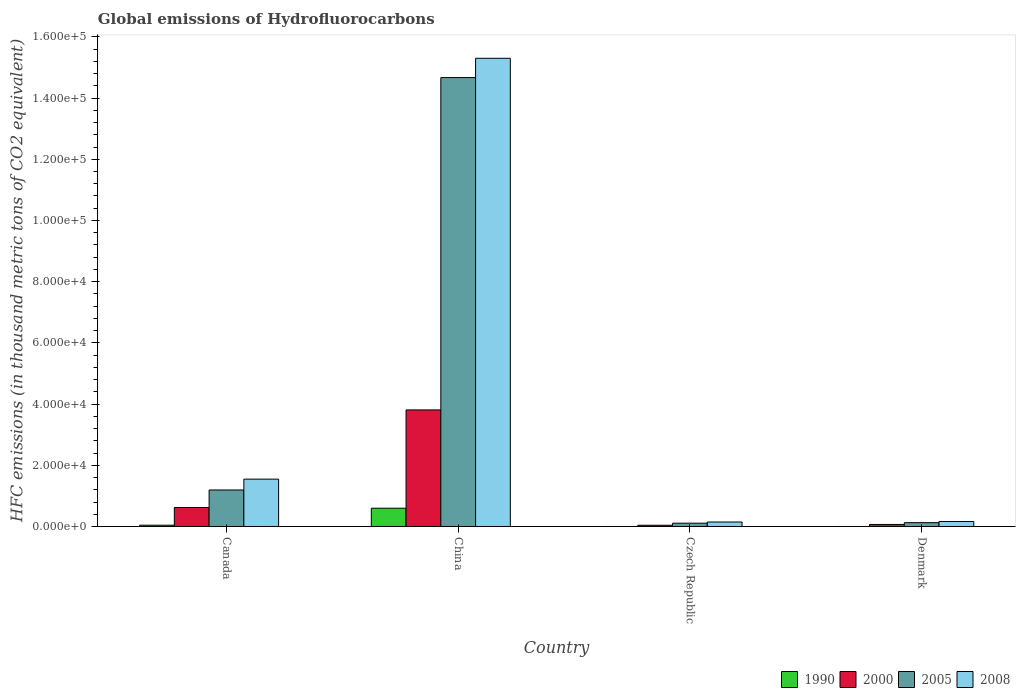How many different coloured bars are there?
Give a very brief answer. 4. Are the number of bars per tick equal to the number of legend labels?
Your answer should be compact. Yes. Are the number of bars on each tick of the X-axis equal?
Give a very brief answer. Yes. How many bars are there on the 4th tick from the left?
Offer a very short reply. 4. How many bars are there on the 4th tick from the right?
Ensure brevity in your answer.  4. What is the global emissions of Hydrofluorocarbons in 1990 in Czech Republic?
Your response must be concise. 0.1. Across all countries, what is the maximum global emissions of Hydrofluorocarbons in 2005?
Offer a terse response. 1.47e+05. In which country was the global emissions of Hydrofluorocarbons in 2005 maximum?
Your response must be concise. China. In which country was the global emissions of Hydrofluorocarbons in 1990 minimum?
Offer a very short reply. Czech Republic. What is the total global emissions of Hydrofluorocarbons in 2000 in the graph?
Provide a succinct answer. 4.54e+04. What is the difference between the global emissions of Hydrofluorocarbons in 2008 in China and that in Denmark?
Ensure brevity in your answer.  1.51e+05. What is the difference between the global emissions of Hydrofluorocarbons in 1990 in China and the global emissions of Hydrofluorocarbons in 2005 in Canada?
Offer a terse response. -5958.3. What is the average global emissions of Hydrofluorocarbons in 2005 per country?
Offer a terse response. 4.02e+04. What is the difference between the global emissions of Hydrofluorocarbons of/in 1990 and global emissions of Hydrofluorocarbons of/in 2005 in China?
Your response must be concise. -1.41e+05. What is the ratio of the global emissions of Hydrofluorocarbons in 2000 in Canada to that in Denmark?
Provide a short and direct response. 9.37. Is the global emissions of Hydrofluorocarbons in 2005 in China less than that in Czech Republic?
Provide a short and direct response. No. Is the difference between the global emissions of Hydrofluorocarbons in 1990 in Canada and Czech Republic greater than the difference between the global emissions of Hydrofluorocarbons in 2005 in Canada and Czech Republic?
Offer a very short reply. No. What is the difference between the highest and the second highest global emissions of Hydrofluorocarbons in 1990?
Offer a terse response. -5551.6. What is the difference between the highest and the lowest global emissions of Hydrofluorocarbons in 1990?
Keep it short and to the point. 5970. Is the sum of the global emissions of Hydrofluorocarbons in 2005 in China and Czech Republic greater than the maximum global emissions of Hydrofluorocarbons in 2000 across all countries?
Your response must be concise. Yes. What does the 3rd bar from the left in China represents?
Offer a very short reply. 2005. What does the 3rd bar from the right in China represents?
Provide a short and direct response. 2000. Are all the bars in the graph horizontal?
Keep it short and to the point. No. Are the values on the major ticks of Y-axis written in scientific E-notation?
Make the answer very short. Yes. Does the graph contain grids?
Your response must be concise. No. How many legend labels are there?
Offer a terse response. 4. What is the title of the graph?
Your answer should be very brief. Global emissions of Hydrofluorocarbons. What is the label or title of the Y-axis?
Give a very brief answer. HFC emissions (in thousand metric tons of CO2 equivalent). What is the HFC emissions (in thousand metric tons of CO2 equivalent) of 1990 in Canada?
Offer a very short reply. 418.5. What is the HFC emissions (in thousand metric tons of CO2 equivalent) in 2000 in Canada?
Make the answer very short. 6202.8. What is the HFC emissions (in thousand metric tons of CO2 equivalent) of 2005 in Canada?
Your answer should be compact. 1.19e+04. What is the HFC emissions (in thousand metric tons of CO2 equivalent) in 2008 in Canada?
Offer a terse response. 1.55e+04. What is the HFC emissions (in thousand metric tons of CO2 equivalent) in 1990 in China?
Ensure brevity in your answer.  5970.1. What is the HFC emissions (in thousand metric tons of CO2 equivalent) of 2000 in China?
Provide a succinct answer. 3.81e+04. What is the HFC emissions (in thousand metric tons of CO2 equivalent) of 2005 in China?
Your answer should be very brief. 1.47e+05. What is the HFC emissions (in thousand metric tons of CO2 equivalent) of 2008 in China?
Your response must be concise. 1.53e+05. What is the HFC emissions (in thousand metric tons of CO2 equivalent) of 1990 in Czech Republic?
Make the answer very short. 0.1. What is the HFC emissions (in thousand metric tons of CO2 equivalent) in 2000 in Czech Republic?
Keep it short and to the point. 399.5. What is the HFC emissions (in thousand metric tons of CO2 equivalent) of 2005 in Czech Republic?
Give a very brief answer. 1078.7. What is the HFC emissions (in thousand metric tons of CO2 equivalent) in 2008 in Czech Republic?
Offer a very short reply. 1459. What is the HFC emissions (in thousand metric tons of CO2 equivalent) in 2000 in Denmark?
Make the answer very short. 662.2. What is the HFC emissions (in thousand metric tons of CO2 equivalent) in 2005 in Denmark?
Offer a terse response. 1249.5. What is the HFC emissions (in thousand metric tons of CO2 equivalent) of 2008 in Denmark?
Give a very brief answer. 1629.6. Across all countries, what is the maximum HFC emissions (in thousand metric tons of CO2 equivalent) in 1990?
Provide a short and direct response. 5970.1. Across all countries, what is the maximum HFC emissions (in thousand metric tons of CO2 equivalent) in 2000?
Make the answer very short. 3.81e+04. Across all countries, what is the maximum HFC emissions (in thousand metric tons of CO2 equivalent) in 2005?
Keep it short and to the point. 1.47e+05. Across all countries, what is the maximum HFC emissions (in thousand metric tons of CO2 equivalent) of 2008?
Offer a terse response. 1.53e+05. Across all countries, what is the minimum HFC emissions (in thousand metric tons of CO2 equivalent) of 2000?
Your answer should be compact. 399.5. Across all countries, what is the minimum HFC emissions (in thousand metric tons of CO2 equivalent) in 2005?
Keep it short and to the point. 1078.7. Across all countries, what is the minimum HFC emissions (in thousand metric tons of CO2 equivalent) in 2008?
Your answer should be compact. 1459. What is the total HFC emissions (in thousand metric tons of CO2 equivalent) in 1990 in the graph?
Provide a succinct answer. 6389. What is the total HFC emissions (in thousand metric tons of CO2 equivalent) of 2000 in the graph?
Your answer should be very brief. 4.54e+04. What is the total HFC emissions (in thousand metric tons of CO2 equivalent) of 2005 in the graph?
Provide a succinct answer. 1.61e+05. What is the total HFC emissions (in thousand metric tons of CO2 equivalent) in 2008 in the graph?
Offer a terse response. 1.72e+05. What is the difference between the HFC emissions (in thousand metric tons of CO2 equivalent) of 1990 in Canada and that in China?
Your answer should be compact. -5551.6. What is the difference between the HFC emissions (in thousand metric tons of CO2 equivalent) in 2000 in Canada and that in China?
Offer a very short reply. -3.19e+04. What is the difference between the HFC emissions (in thousand metric tons of CO2 equivalent) in 2005 in Canada and that in China?
Your answer should be compact. -1.35e+05. What is the difference between the HFC emissions (in thousand metric tons of CO2 equivalent) in 2008 in Canada and that in China?
Provide a short and direct response. -1.38e+05. What is the difference between the HFC emissions (in thousand metric tons of CO2 equivalent) in 1990 in Canada and that in Czech Republic?
Provide a succinct answer. 418.4. What is the difference between the HFC emissions (in thousand metric tons of CO2 equivalent) of 2000 in Canada and that in Czech Republic?
Keep it short and to the point. 5803.3. What is the difference between the HFC emissions (in thousand metric tons of CO2 equivalent) in 2005 in Canada and that in Czech Republic?
Make the answer very short. 1.08e+04. What is the difference between the HFC emissions (in thousand metric tons of CO2 equivalent) of 2008 in Canada and that in Czech Republic?
Offer a very short reply. 1.40e+04. What is the difference between the HFC emissions (in thousand metric tons of CO2 equivalent) in 1990 in Canada and that in Denmark?
Your answer should be compact. 418.2. What is the difference between the HFC emissions (in thousand metric tons of CO2 equivalent) in 2000 in Canada and that in Denmark?
Provide a short and direct response. 5540.6. What is the difference between the HFC emissions (in thousand metric tons of CO2 equivalent) of 2005 in Canada and that in Denmark?
Your response must be concise. 1.07e+04. What is the difference between the HFC emissions (in thousand metric tons of CO2 equivalent) of 2008 in Canada and that in Denmark?
Give a very brief answer. 1.38e+04. What is the difference between the HFC emissions (in thousand metric tons of CO2 equivalent) in 1990 in China and that in Czech Republic?
Give a very brief answer. 5970. What is the difference between the HFC emissions (in thousand metric tons of CO2 equivalent) in 2000 in China and that in Czech Republic?
Keep it short and to the point. 3.77e+04. What is the difference between the HFC emissions (in thousand metric tons of CO2 equivalent) of 2005 in China and that in Czech Republic?
Provide a succinct answer. 1.46e+05. What is the difference between the HFC emissions (in thousand metric tons of CO2 equivalent) of 2008 in China and that in Czech Republic?
Offer a terse response. 1.52e+05. What is the difference between the HFC emissions (in thousand metric tons of CO2 equivalent) of 1990 in China and that in Denmark?
Ensure brevity in your answer.  5969.8. What is the difference between the HFC emissions (in thousand metric tons of CO2 equivalent) in 2000 in China and that in Denmark?
Provide a short and direct response. 3.74e+04. What is the difference between the HFC emissions (in thousand metric tons of CO2 equivalent) in 2005 in China and that in Denmark?
Your response must be concise. 1.45e+05. What is the difference between the HFC emissions (in thousand metric tons of CO2 equivalent) of 2008 in China and that in Denmark?
Your answer should be very brief. 1.51e+05. What is the difference between the HFC emissions (in thousand metric tons of CO2 equivalent) in 2000 in Czech Republic and that in Denmark?
Ensure brevity in your answer.  -262.7. What is the difference between the HFC emissions (in thousand metric tons of CO2 equivalent) in 2005 in Czech Republic and that in Denmark?
Give a very brief answer. -170.8. What is the difference between the HFC emissions (in thousand metric tons of CO2 equivalent) in 2008 in Czech Republic and that in Denmark?
Offer a very short reply. -170.6. What is the difference between the HFC emissions (in thousand metric tons of CO2 equivalent) in 1990 in Canada and the HFC emissions (in thousand metric tons of CO2 equivalent) in 2000 in China?
Provide a short and direct response. -3.77e+04. What is the difference between the HFC emissions (in thousand metric tons of CO2 equivalent) of 1990 in Canada and the HFC emissions (in thousand metric tons of CO2 equivalent) of 2005 in China?
Your answer should be compact. -1.46e+05. What is the difference between the HFC emissions (in thousand metric tons of CO2 equivalent) of 1990 in Canada and the HFC emissions (in thousand metric tons of CO2 equivalent) of 2008 in China?
Offer a very short reply. -1.53e+05. What is the difference between the HFC emissions (in thousand metric tons of CO2 equivalent) of 2000 in Canada and the HFC emissions (in thousand metric tons of CO2 equivalent) of 2005 in China?
Offer a terse response. -1.40e+05. What is the difference between the HFC emissions (in thousand metric tons of CO2 equivalent) of 2000 in Canada and the HFC emissions (in thousand metric tons of CO2 equivalent) of 2008 in China?
Provide a succinct answer. -1.47e+05. What is the difference between the HFC emissions (in thousand metric tons of CO2 equivalent) of 2005 in Canada and the HFC emissions (in thousand metric tons of CO2 equivalent) of 2008 in China?
Your answer should be very brief. -1.41e+05. What is the difference between the HFC emissions (in thousand metric tons of CO2 equivalent) in 1990 in Canada and the HFC emissions (in thousand metric tons of CO2 equivalent) in 2005 in Czech Republic?
Keep it short and to the point. -660.2. What is the difference between the HFC emissions (in thousand metric tons of CO2 equivalent) of 1990 in Canada and the HFC emissions (in thousand metric tons of CO2 equivalent) of 2008 in Czech Republic?
Provide a succinct answer. -1040.5. What is the difference between the HFC emissions (in thousand metric tons of CO2 equivalent) of 2000 in Canada and the HFC emissions (in thousand metric tons of CO2 equivalent) of 2005 in Czech Republic?
Your answer should be very brief. 5124.1. What is the difference between the HFC emissions (in thousand metric tons of CO2 equivalent) of 2000 in Canada and the HFC emissions (in thousand metric tons of CO2 equivalent) of 2008 in Czech Republic?
Your response must be concise. 4743.8. What is the difference between the HFC emissions (in thousand metric tons of CO2 equivalent) of 2005 in Canada and the HFC emissions (in thousand metric tons of CO2 equivalent) of 2008 in Czech Republic?
Your answer should be compact. 1.05e+04. What is the difference between the HFC emissions (in thousand metric tons of CO2 equivalent) in 1990 in Canada and the HFC emissions (in thousand metric tons of CO2 equivalent) in 2000 in Denmark?
Your response must be concise. -243.7. What is the difference between the HFC emissions (in thousand metric tons of CO2 equivalent) of 1990 in Canada and the HFC emissions (in thousand metric tons of CO2 equivalent) of 2005 in Denmark?
Provide a short and direct response. -831. What is the difference between the HFC emissions (in thousand metric tons of CO2 equivalent) in 1990 in Canada and the HFC emissions (in thousand metric tons of CO2 equivalent) in 2008 in Denmark?
Ensure brevity in your answer.  -1211.1. What is the difference between the HFC emissions (in thousand metric tons of CO2 equivalent) in 2000 in Canada and the HFC emissions (in thousand metric tons of CO2 equivalent) in 2005 in Denmark?
Offer a very short reply. 4953.3. What is the difference between the HFC emissions (in thousand metric tons of CO2 equivalent) in 2000 in Canada and the HFC emissions (in thousand metric tons of CO2 equivalent) in 2008 in Denmark?
Ensure brevity in your answer.  4573.2. What is the difference between the HFC emissions (in thousand metric tons of CO2 equivalent) of 2005 in Canada and the HFC emissions (in thousand metric tons of CO2 equivalent) of 2008 in Denmark?
Offer a terse response. 1.03e+04. What is the difference between the HFC emissions (in thousand metric tons of CO2 equivalent) of 1990 in China and the HFC emissions (in thousand metric tons of CO2 equivalent) of 2000 in Czech Republic?
Provide a short and direct response. 5570.6. What is the difference between the HFC emissions (in thousand metric tons of CO2 equivalent) in 1990 in China and the HFC emissions (in thousand metric tons of CO2 equivalent) in 2005 in Czech Republic?
Your response must be concise. 4891.4. What is the difference between the HFC emissions (in thousand metric tons of CO2 equivalent) in 1990 in China and the HFC emissions (in thousand metric tons of CO2 equivalent) in 2008 in Czech Republic?
Keep it short and to the point. 4511.1. What is the difference between the HFC emissions (in thousand metric tons of CO2 equivalent) in 2000 in China and the HFC emissions (in thousand metric tons of CO2 equivalent) in 2005 in Czech Republic?
Your answer should be very brief. 3.70e+04. What is the difference between the HFC emissions (in thousand metric tons of CO2 equivalent) in 2000 in China and the HFC emissions (in thousand metric tons of CO2 equivalent) in 2008 in Czech Republic?
Provide a succinct answer. 3.66e+04. What is the difference between the HFC emissions (in thousand metric tons of CO2 equivalent) in 2005 in China and the HFC emissions (in thousand metric tons of CO2 equivalent) in 2008 in Czech Republic?
Offer a terse response. 1.45e+05. What is the difference between the HFC emissions (in thousand metric tons of CO2 equivalent) of 1990 in China and the HFC emissions (in thousand metric tons of CO2 equivalent) of 2000 in Denmark?
Offer a very short reply. 5307.9. What is the difference between the HFC emissions (in thousand metric tons of CO2 equivalent) of 1990 in China and the HFC emissions (in thousand metric tons of CO2 equivalent) of 2005 in Denmark?
Provide a succinct answer. 4720.6. What is the difference between the HFC emissions (in thousand metric tons of CO2 equivalent) in 1990 in China and the HFC emissions (in thousand metric tons of CO2 equivalent) in 2008 in Denmark?
Your answer should be very brief. 4340.5. What is the difference between the HFC emissions (in thousand metric tons of CO2 equivalent) of 2000 in China and the HFC emissions (in thousand metric tons of CO2 equivalent) of 2005 in Denmark?
Your answer should be very brief. 3.68e+04. What is the difference between the HFC emissions (in thousand metric tons of CO2 equivalent) of 2000 in China and the HFC emissions (in thousand metric tons of CO2 equivalent) of 2008 in Denmark?
Provide a short and direct response. 3.65e+04. What is the difference between the HFC emissions (in thousand metric tons of CO2 equivalent) in 2005 in China and the HFC emissions (in thousand metric tons of CO2 equivalent) in 2008 in Denmark?
Provide a short and direct response. 1.45e+05. What is the difference between the HFC emissions (in thousand metric tons of CO2 equivalent) in 1990 in Czech Republic and the HFC emissions (in thousand metric tons of CO2 equivalent) in 2000 in Denmark?
Provide a succinct answer. -662.1. What is the difference between the HFC emissions (in thousand metric tons of CO2 equivalent) in 1990 in Czech Republic and the HFC emissions (in thousand metric tons of CO2 equivalent) in 2005 in Denmark?
Give a very brief answer. -1249.4. What is the difference between the HFC emissions (in thousand metric tons of CO2 equivalent) of 1990 in Czech Republic and the HFC emissions (in thousand metric tons of CO2 equivalent) of 2008 in Denmark?
Make the answer very short. -1629.5. What is the difference between the HFC emissions (in thousand metric tons of CO2 equivalent) in 2000 in Czech Republic and the HFC emissions (in thousand metric tons of CO2 equivalent) in 2005 in Denmark?
Ensure brevity in your answer.  -850. What is the difference between the HFC emissions (in thousand metric tons of CO2 equivalent) in 2000 in Czech Republic and the HFC emissions (in thousand metric tons of CO2 equivalent) in 2008 in Denmark?
Give a very brief answer. -1230.1. What is the difference between the HFC emissions (in thousand metric tons of CO2 equivalent) in 2005 in Czech Republic and the HFC emissions (in thousand metric tons of CO2 equivalent) in 2008 in Denmark?
Your answer should be very brief. -550.9. What is the average HFC emissions (in thousand metric tons of CO2 equivalent) in 1990 per country?
Your answer should be very brief. 1597.25. What is the average HFC emissions (in thousand metric tons of CO2 equivalent) in 2000 per country?
Your answer should be compact. 1.13e+04. What is the average HFC emissions (in thousand metric tons of CO2 equivalent) of 2005 per country?
Make the answer very short. 4.02e+04. What is the average HFC emissions (in thousand metric tons of CO2 equivalent) of 2008 per country?
Give a very brief answer. 4.29e+04. What is the difference between the HFC emissions (in thousand metric tons of CO2 equivalent) of 1990 and HFC emissions (in thousand metric tons of CO2 equivalent) of 2000 in Canada?
Your answer should be compact. -5784.3. What is the difference between the HFC emissions (in thousand metric tons of CO2 equivalent) of 1990 and HFC emissions (in thousand metric tons of CO2 equivalent) of 2005 in Canada?
Ensure brevity in your answer.  -1.15e+04. What is the difference between the HFC emissions (in thousand metric tons of CO2 equivalent) in 1990 and HFC emissions (in thousand metric tons of CO2 equivalent) in 2008 in Canada?
Give a very brief answer. -1.51e+04. What is the difference between the HFC emissions (in thousand metric tons of CO2 equivalent) in 2000 and HFC emissions (in thousand metric tons of CO2 equivalent) in 2005 in Canada?
Your answer should be very brief. -5725.6. What is the difference between the HFC emissions (in thousand metric tons of CO2 equivalent) in 2000 and HFC emissions (in thousand metric tons of CO2 equivalent) in 2008 in Canada?
Your answer should be very brief. -9272. What is the difference between the HFC emissions (in thousand metric tons of CO2 equivalent) in 2005 and HFC emissions (in thousand metric tons of CO2 equivalent) in 2008 in Canada?
Offer a very short reply. -3546.4. What is the difference between the HFC emissions (in thousand metric tons of CO2 equivalent) of 1990 and HFC emissions (in thousand metric tons of CO2 equivalent) of 2000 in China?
Make the answer very short. -3.21e+04. What is the difference between the HFC emissions (in thousand metric tons of CO2 equivalent) of 1990 and HFC emissions (in thousand metric tons of CO2 equivalent) of 2005 in China?
Ensure brevity in your answer.  -1.41e+05. What is the difference between the HFC emissions (in thousand metric tons of CO2 equivalent) of 1990 and HFC emissions (in thousand metric tons of CO2 equivalent) of 2008 in China?
Keep it short and to the point. -1.47e+05. What is the difference between the HFC emissions (in thousand metric tons of CO2 equivalent) in 2000 and HFC emissions (in thousand metric tons of CO2 equivalent) in 2005 in China?
Give a very brief answer. -1.09e+05. What is the difference between the HFC emissions (in thousand metric tons of CO2 equivalent) in 2000 and HFC emissions (in thousand metric tons of CO2 equivalent) in 2008 in China?
Provide a short and direct response. -1.15e+05. What is the difference between the HFC emissions (in thousand metric tons of CO2 equivalent) in 2005 and HFC emissions (in thousand metric tons of CO2 equivalent) in 2008 in China?
Offer a terse response. -6309. What is the difference between the HFC emissions (in thousand metric tons of CO2 equivalent) in 1990 and HFC emissions (in thousand metric tons of CO2 equivalent) in 2000 in Czech Republic?
Give a very brief answer. -399.4. What is the difference between the HFC emissions (in thousand metric tons of CO2 equivalent) in 1990 and HFC emissions (in thousand metric tons of CO2 equivalent) in 2005 in Czech Republic?
Give a very brief answer. -1078.6. What is the difference between the HFC emissions (in thousand metric tons of CO2 equivalent) of 1990 and HFC emissions (in thousand metric tons of CO2 equivalent) of 2008 in Czech Republic?
Your answer should be very brief. -1458.9. What is the difference between the HFC emissions (in thousand metric tons of CO2 equivalent) in 2000 and HFC emissions (in thousand metric tons of CO2 equivalent) in 2005 in Czech Republic?
Provide a succinct answer. -679.2. What is the difference between the HFC emissions (in thousand metric tons of CO2 equivalent) in 2000 and HFC emissions (in thousand metric tons of CO2 equivalent) in 2008 in Czech Republic?
Your answer should be compact. -1059.5. What is the difference between the HFC emissions (in thousand metric tons of CO2 equivalent) of 2005 and HFC emissions (in thousand metric tons of CO2 equivalent) of 2008 in Czech Republic?
Your response must be concise. -380.3. What is the difference between the HFC emissions (in thousand metric tons of CO2 equivalent) in 1990 and HFC emissions (in thousand metric tons of CO2 equivalent) in 2000 in Denmark?
Provide a short and direct response. -661.9. What is the difference between the HFC emissions (in thousand metric tons of CO2 equivalent) in 1990 and HFC emissions (in thousand metric tons of CO2 equivalent) in 2005 in Denmark?
Provide a succinct answer. -1249.2. What is the difference between the HFC emissions (in thousand metric tons of CO2 equivalent) of 1990 and HFC emissions (in thousand metric tons of CO2 equivalent) of 2008 in Denmark?
Ensure brevity in your answer.  -1629.3. What is the difference between the HFC emissions (in thousand metric tons of CO2 equivalent) of 2000 and HFC emissions (in thousand metric tons of CO2 equivalent) of 2005 in Denmark?
Ensure brevity in your answer.  -587.3. What is the difference between the HFC emissions (in thousand metric tons of CO2 equivalent) in 2000 and HFC emissions (in thousand metric tons of CO2 equivalent) in 2008 in Denmark?
Provide a succinct answer. -967.4. What is the difference between the HFC emissions (in thousand metric tons of CO2 equivalent) in 2005 and HFC emissions (in thousand metric tons of CO2 equivalent) in 2008 in Denmark?
Your answer should be compact. -380.1. What is the ratio of the HFC emissions (in thousand metric tons of CO2 equivalent) of 1990 in Canada to that in China?
Offer a very short reply. 0.07. What is the ratio of the HFC emissions (in thousand metric tons of CO2 equivalent) in 2000 in Canada to that in China?
Give a very brief answer. 0.16. What is the ratio of the HFC emissions (in thousand metric tons of CO2 equivalent) of 2005 in Canada to that in China?
Provide a succinct answer. 0.08. What is the ratio of the HFC emissions (in thousand metric tons of CO2 equivalent) in 2008 in Canada to that in China?
Keep it short and to the point. 0.1. What is the ratio of the HFC emissions (in thousand metric tons of CO2 equivalent) of 1990 in Canada to that in Czech Republic?
Offer a terse response. 4185. What is the ratio of the HFC emissions (in thousand metric tons of CO2 equivalent) of 2000 in Canada to that in Czech Republic?
Make the answer very short. 15.53. What is the ratio of the HFC emissions (in thousand metric tons of CO2 equivalent) in 2005 in Canada to that in Czech Republic?
Provide a short and direct response. 11.06. What is the ratio of the HFC emissions (in thousand metric tons of CO2 equivalent) in 2008 in Canada to that in Czech Republic?
Your answer should be compact. 10.61. What is the ratio of the HFC emissions (in thousand metric tons of CO2 equivalent) of 1990 in Canada to that in Denmark?
Offer a very short reply. 1395. What is the ratio of the HFC emissions (in thousand metric tons of CO2 equivalent) of 2000 in Canada to that in Denmark?
Offer a very short reply. 9.37. What is the ratio of the HFC emissions (in thousand metric tons of CO2 equivalent) in 2005 in Canada to that in Denmark?
Keep it short and to the point. 9.55. What is the ratio of the HFC emissions (in thousand metric tons of CO2 equivalent) of 2008 in Canada to that in Denmark?
Ensure brevity in your answer.  9.5. What is the ratio of the HFC emissions (in thousand metric tons of CO2 equivalent) in 1990 in China to that in Czech Republic?
Make the answer very short. 5.97e+04. What is the ratio of the HFC emissions (in thousand metric tons of CO2 equivalent) of 2000 in China to that in Czech Republic?
Provide a short and direct response. 95.35. What is the ratio of the HFC emissions (in thousand metric tons of CO2 equivalent) of 2005 in China to that in Czech Republic?
Your answer should be very brief. 135.99. What is the ratio of the HFC emissions (in thousand metric tons of CO2 equivalent) of 2008 in China to that in Czech Republic?
Offer a very short reply. 104.87. What is the ratio of the HFC emissions (in thousand metric tons of CO2 equivalent) in 1990 in China to that in Denmark?
Your answer should be compact. 1.99e+04. What is the ratio of the HFC emissions (in thousand metric tons of CO2 equivalent) of 2000 in China to that in Denmark?
Give a very brief answer. 57.53. What is the ratio of the HFC emissions (in thousand metric tons of CO2 equivalent) in 2005 in China to that in Denmark?
Ensure brevity in your answer.  117.4. What is the ratio of the HFC emissions (in thousand metric tons of CO2 equivalent) in 2008 in China to that in Denmark?
Give a very brief answer. 93.89. What is the ratio of the HFC emissions (in thousand metric tons of CO2 equivalent) of 1990 in Czech Republic to that in Denmark?
Ensure brevity in your answer.  0.33. What is the ratio of the HFC emissions (in thousand metric tons of CO2 equivalent) of 2000 in Czech Republic to that in Denmark?
Make the answer very short. 0.6. What is the ratio of the HFC emissions (in thousand metric tons of CO2 equivalent) in 2005 in Czech Republic to that in Denmark?
Make the answer very short. 0.86. What is the ratio of the HFC emissions (in thousand metric tons of CO2 equivalent) of 2008 in Czech Republic to that in Denmark?
Provide a succinct answer. 0.9. What is the difference between the highest and the second highest HFC emissions (in thousand metric tons of CO2 equivalent) of 1990?
Ensure brevity in your answer.  5551.6. What is the difference between the highest and the second highest HFC emissions (in thousand metric tons of CO2 equivalent) of 2000?
Provide a short and direct response. 3.19e+04. What is the difference between the highest and the second highest HFC emissions (in thousand metric tons of CO2 equivalent) in 2005?
Your answer should be very brief. 1.35e+05. What is the difference between the highest and the second highest HFC emissions (in thousand metric tons of CO2 equivalent) in 2008?
Ensure brevity in your answer.  1.38e+05. What is the difference between the highest and the lowest HFC emissions (in thousand metric tons of CO2 equivalent) in 1990?
Your response must be concise. 5970. What is the difference between the highest and the lowest HFC emissions (in thousand metric tons of CO2 equivalent) in 2000?
Make the answer very short. 3.77e+04. What is the difference between the highest and the lowest HFC emissions (in thousand metric tons of CO2 equivalent) of 2005?
Your response must be concise. 1.46e+05. What is the difference between the highest and the lowest HFC emissions (in thousand metric tons of CO2 equivalent) in 2008?
Provide a succinct answer. 1.52e+05. 